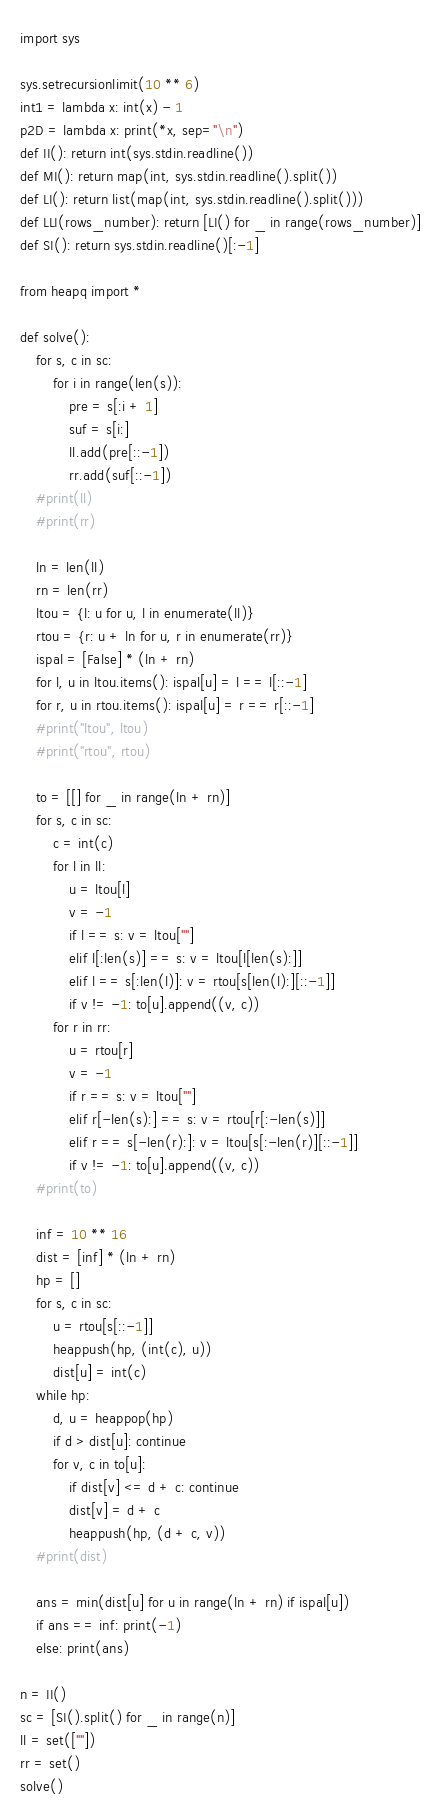<code> <loc_0><loc_0><loc_500><loc_500><_Python_>import sys

sys.setrecursionlimit(10 ** 6)
int1 = lambda x: int(x) - 1
p2D = lambda x: print(*x, sep="\n")
def II(): return int(sys.stdin.readline())
def MI(): return map(int, sys.stdin.readline().split())
def LI(): return list(map(int, sys.stdin.readline().split()))
def LLI(rows_number): return [LI() for _ in range(rows_number)]
def SI(): return sys.stdin.readline()[:-1]

from heapq import *

def solve():
    for s, c in sc:
        for i in range(len(s)):
            pre = s[:i + 1]
            suf = s[i:]
            ll.add(pre[::-1])
            rr.add(suf[::-1])
    #print(ll)
    #print(rr)

    ln = len(ll)
    rn = len(rr)
    ltou = {l: u for u, l in enumerate(ll)}
    rtou = {r: u + ln for u, r in enumerate(rr)}
    ispal = [False] * (ln + rn)
    for l, u in ltou.items(): ispal[u] = l == l[::-1]
    for r, u in rtou.items(): ispal[u] = r == r[::-1]
    #print("ltou", ltou)
    #print("rtou", rtou)

    to = [[] for _ in range(ln + rn)]
    for s, c in sc:
        c = int(c)
        for l in ll:
            u = ltou[l]
            v = -1
            if l == s: v = ltou[""]
            elif l[:len(s)] == s: v = ltou[l[len(s):]]
            elif l == s[:len(l)]: v = rtou[s[len(l):][::-1]]
            if v != -1: to[u].append((v, c))
        for r in rr:
            u = rtou[r]
            v = -1
            if r == s: v = ltou[""]
            elif r[-len(s):] == s: v = rtou[r[:-len(s)]]
            elif r == s[-len(r):]: v = ltou[s[:-len(r)][::-1]]
            if v != -1: to[u].append((v, c))
    #print(to)

    inf = 10 ** 16
    dist = [inf] * (ln + rn)
    hp = []
    for s, c in sc:
        u = rtou[s[::-1]]
        heappush(hp, (int(c), u))
        dist[u] = int(c)
    while hp:
        d, u = heappop(hp)
        if d > dist[u]: continue
        for v, c in to[u]:
            if dist[v] <= d + c: continue
            dist[v] = d + c
            heappush(hp, (d + c, v))
    #print(dist)

    ans = min(dist[u] for u in range(ln + rn) if ispal[u])
    if ans == inf: print(-1)
    else: print(ans)

n = II()
sc = [SI().split() for _ in range(n)]
ll = set([""])
rr = set()
solve()
</code> 